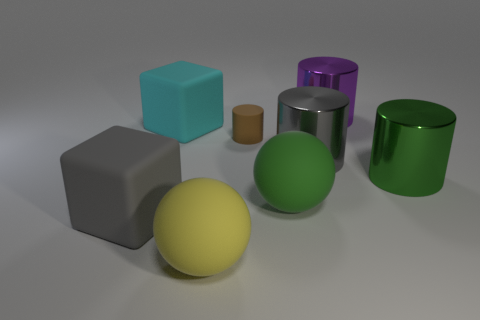Are there more large cylinders that are in front of the large cyan matte object than green metallic things? Upon carefully examining the image, yes, there are more large cylinders in front of the large cyan matte cube. There is one large purple metallic cylinder and one large green metallic cylinder directly in front of the cyan matte cube, which makes a total of two cylinders. On the other hand, there's just one green metallic item visible. Hence, the count of large cylinders in front of the cyan object indeed exceeds the number of green metallic objects in the image. 